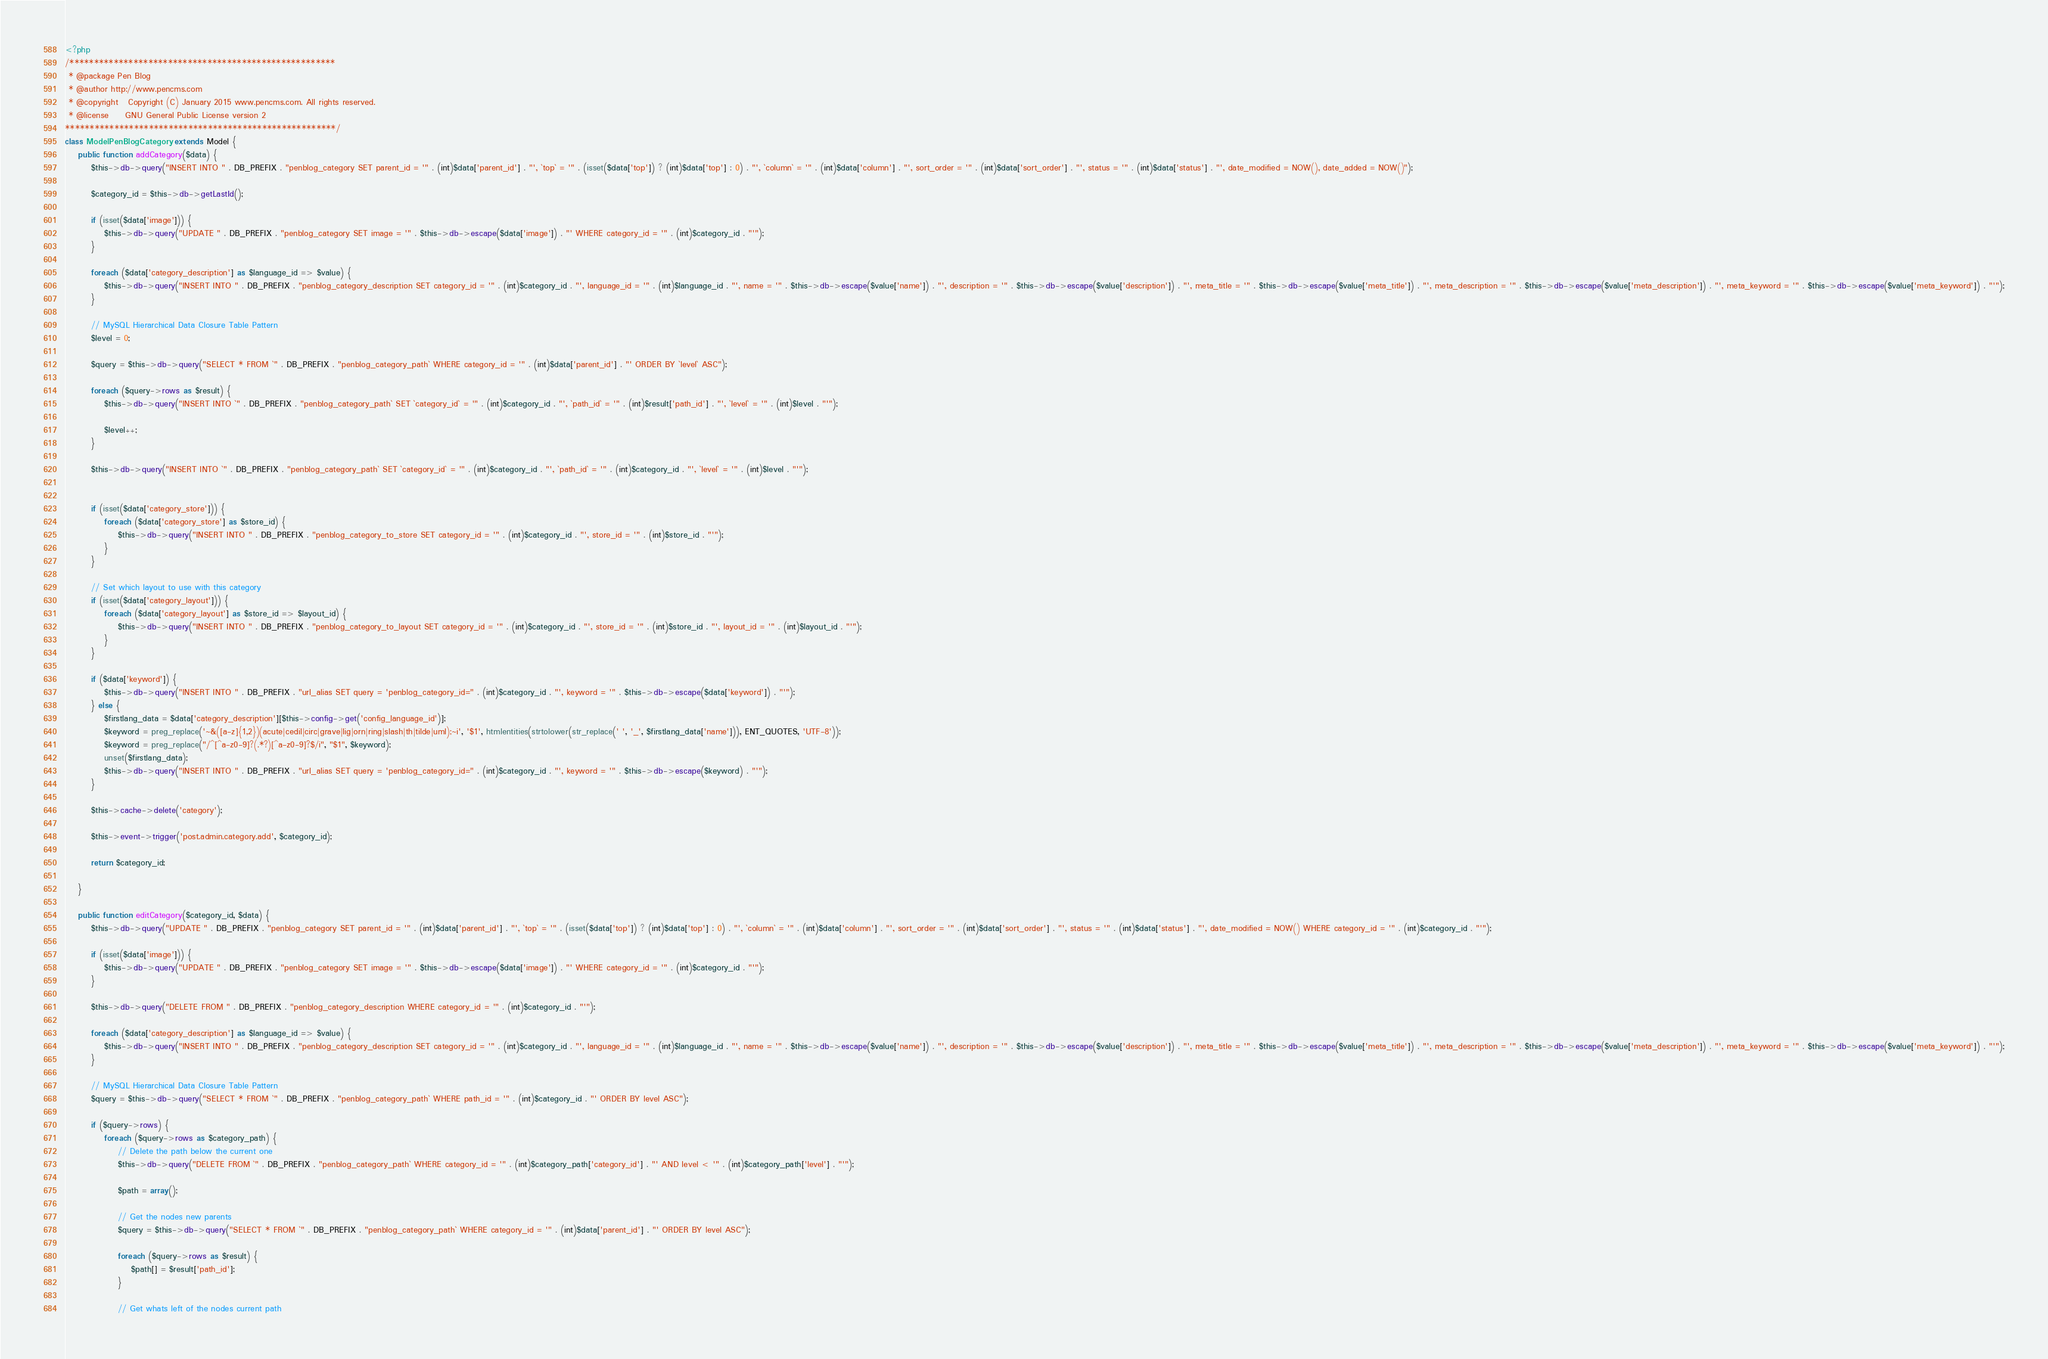Convert code to text. <code><loc_0><loc_0><loc_500><loc_500><_PHP_><?php
/******************************************************
 * @package Pen Blog
 * @author http://www.pencms.com
 * @copyright	Copyright (C) January 2015 www.pencms.com. All rights reserved.
 * @license		GNU General Public License version 2
*******************************************************/
class ModelPenBlogCategory extends Model {
	public function addCategory($data) {
		$this->db->query("INSERT INTO " . DB_PREFIX . "penblog_category SET parent_id = '" . (int)$data['parent_id'] . "', `top` = '" . (isset($data['top']) ? (int)$data['top'] : 0) . "', `column` = '" . (int)$data['column'] . "', sort_order = '" . (int)$data['sort_order'] . "', status = '" . (int)$data['status'] . "', date_modified = NOW(), date_added = NOW()");

		$category_id = $this->db->getLastId();

		if (isset($data['image'])) {
			$this->db->query("UPDATE " . DB_PREFIX . "penblog_category SET image = '" . $this->db->escape($data['image']) . "' WHERE category_id = '" . (int)$category_id . "'");
		}

		foreach ($data['category_description'] as $language_id => $value) {
			$this->db->query("INSERT INTO " . DB_PREFIX . "penblog_category_description SET category_id = '" . (int)$category_id . "', language_id = '" . (int)$language_id . "', name = '" . $this->db->escape($value['name']) . "', description = '" . $this->db->escape($value['description']) . "', meta_title = '" . $this->db->escape($value['meta_title']) . "', meta_description = '" . $this->db->escape($value['meta_description']) . "', meta_keyword = '" . $this->db->escape($value['meta_keyword']) . "'");
		}

		// MySQL Hierarchical Data Closure Table Pattern
		$level = 0;

		$query = $this->db->query("SELECT * FROM `" . DB_PREFIX . "penblog_category_path` WHERE category_id = '" . (int)$data['parent_id'] . "' ORDER BY `level` ASC");

		foreach ($query->rows as $result) {
			$this->db->query("INSERT INTO `" . DB_PREFIX . "penblog_category_path` SET `category_id` = '" . (int)$category_id . "', `path_id` = '" . (int)$result['path_id'] . "', `level` = '" . (int)$level . "'");

			$level++;
		}

		$this->db->query("INSERT INTO `" . DB_PREFIX . "penblog_category_path` SET `category_id` = '" . (int)$category_id . "', `path_id` = '" . (int)$category_id . "', `level` = '" . (int)$level . "'");


		if (isset($data['category_store'])) {
			foreach ($data['category_store'] as $store_id) {
				$this->db->query("INSERT INTO " . DB_PREFIX . "penblog_category_to_store SET category_id = '" . (int)$category_id . "', store_id = '" . (int)$store_id . "'");
			}
		}

		// Set which layout to use with this category
		if (isset($data['category_layout'])) {
			foreach ($data['category_layout'] as $store_id => $layout_id) {
				$this->db->query("INSERT INTO " . DB_PREFIX . "penblog_category_to_layout SET category_id = '" . (int)$category_id . "', store_id = '" . (int)$store_id . "', layout_id = '" . (int)$layout_id . "'");
			}
		}

		if ($data['keyword']) {
			$this->db->query("INSERT INTO " . DB_PREFIX . "url_alias SET query = 'penblog_category_id=" . (int)$category_id . "', keyword = '" . $this->db->escape($data['keyword']) . "'");
		} else {
            $firstlang_data = $data['category_description'][$this->config->get('config_language_id')];
            $keyword = preg_replace('~&([a-z]{1,2})(acute|cedil|circ|grave|lig|orn|ring|slash|th|tilde|uml);~i', '$1', htmlentities(strtolower(str_replace(' ', '_', $firstlang_data['name'])), ENT_QUOTES, 'UTF-8'));
            $keyword = preg_replace("/^[^a-z0-9]?(.*?)[^a-z0-9]?$/i", "$1", $keyword);
            unset($firstlang_data);
            $this->db->query("INSERT INTO " . DB_PREFIX . "url_alias SET query = 'penblog_category_id=" . (int)$category_id . "', keyword = '" . $this->db->escape($keyword) . "'");
        }

		$this->cache->delete('category');

		$this->event->trigger('post.admin.category.add', $category_id);

		return $category_id;

	}

	public function editCategory($category_id, $data) {
		$this->db->query("UPDATE " . DB_PREFIX . "penblog_category SET parent_id = '" . (int)$data['parent_id'] . "', `top` = '" . (isset($data['top']) ? (int)$data['top'] : 0) . "', `column` = '" . (int)$data['column'] . "', sort_order = '" . (int)$data['sort_order'] . "', status = '" . (int)$data['status'] . "', date_modified = NOW() WHERE category_id = '" . (int)$category_id . "'");

		if (isset($data['image'])) {
			$this->db->query("UPDATE " . DB_PREFIX . "penblog_category SET image = '" . $this->db->escape($data['image']) . "' WHERE category_id = '" . (int)$category_id . "'");
		}

		$this->db->query("DELETE FROM " . DB_PREFIX . "penblog_category_description WHERE category_id = '" . (int)$category_id . "'");

		foreach ($data['category_description'] as $language_id => $value) {
			$this->db->query("INSERT INTO " . DB_PREFIX . "penblog_category_description SET category_id = '" . (int)$category_id . "', language_id = '" . (int)$language_id . "', name = '" . $this->db->escape($value['name']) . "', description = '" . $this->db->escape($value['description']) . "', meta_title = '" . $this->db->escape($value['meta_title']) . "', meta_description = '" . $this->db->escape($value['meta_description']) . "', meta_keyword = '" . $this->db->escape($value['meta_keyword']) . "'");
		}

		// MySQL Hierarchical Data Closure Table Pattern
		$query = $this->db->query("SELECT * FROM `" . DB_PREFIX . "penblog_category_path` WHERE path_id = '" . (int)$category_id . "' ORDER BY level ASC");

		if ($query->rows) {
			foreach ($query->rows as $category_path) {
				// Delete the path below the current one
				$this->db->query("DELETE FROM `" . DB_PREFIX . "penblog_category_path` WHERE category_id = '" . (int)$category_path['category_id'] . "' AND level < '" . (int)$category_path['level'] . "'");

				$path = array();

				// Get the nodes new parents
				$query = $this->db->query("SELECT * FROM `" . DB_PREFIX . "penblog_category_path` WHERE category_id = '" . (int)$data['parent_id'] . "' ORDER BY level ASC");

				foreach ($query->rows as $result) {
					$path[] = $result['path_id'];
				}

				// Get whats left of the nodes current path</code> 